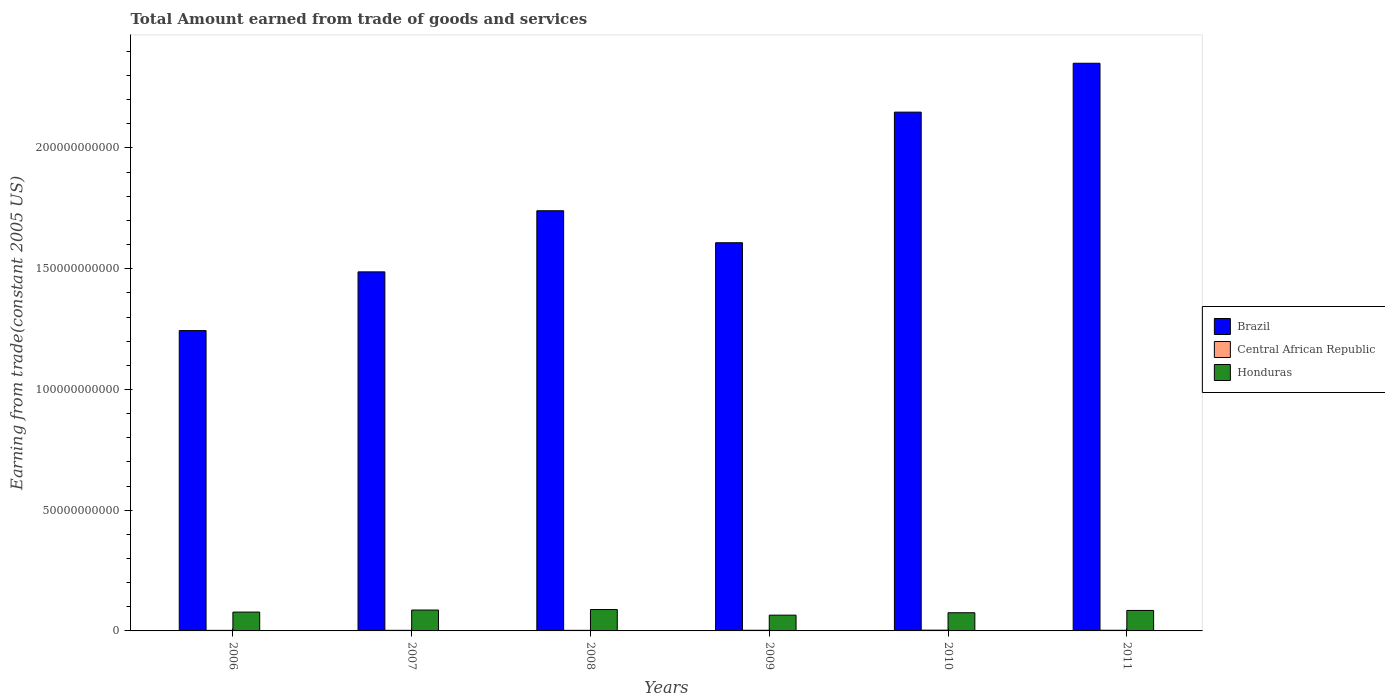How many groups of bars are there?
Your response must be concise. 6. Are the number of bars per tick equal to the number of legend labels?
Offer a terse response. Yes. Are the number of bars on each tick of the X-axis equal?
Offer a terse response. Yes. How many bars are there on the 6th tick from the left?
Your answer should be very brief. 3. What is the label of the 5th group of bars from the left?
Ensure brevity in your answer.  2010. In how many cases, is the number of bars for a given year not equal to the number of legend labels?
Provide a succinct answer. 0. What is the total amount earned by trading goods and services in Honduras in 2008?
Keep it short and to the point. 8.85e+09. Across all years, what is the maximum total amount earned by trading goods and services in Honduras?
Ensure brevity in your answer.  8.85e+09. Across all years, what is the minimum total amount earned by trading goods and services in Central African Republic?
Your answer should be very brief. 2.32e+08. In which year was the total amount earned by trading goods and services in Brazil minimum?
Make the answer very short. 2006. What is the total total amount earned by trading goods and services in Brazil in the graph?
Your answer should be very brief. 1.06e+12. What is the difference between the total amount earned by trading goods and services in Honduras in 2006 and that in 2007?
Provide a short and direct response. -8.49e+08. What is the difference between the total amount earned by trading goods and services in Brazil in 2011 and the total amount earned by trading goods and services in Central African Republic in 2006?
Your answer should be very brief. 2.35e+11. What is the average total amount earned by trading goods and services in Brazil per year?
Your answer should be very brief. 1.76e+11. In the year 2010, what is the difference between the total amount earned by trading goods and services in Central African Republic and total amount earned by trading goods and services in Brazil?
Your response must be concise. -2.15e+11. In how many years, is the total amount earned by trading goods and services in Brazil greater than 120000000000 US$?
Provide a short and direct response. 6. What is the ratio of the total amount earned by trading goods and services in Brazil in 2006 to that in 2007?
Provide a short and direct response. 0.84. Is the total amount earned by trading goods and services in Honduras in 2006 less than that in 2011?
Provide a succinct answer. Yes. Is the difference between the total amount earned by trading goods and services in Central African Republic in 2007 and 2009 greater than the difference between the total amount earned by trading goods and services in Brazil in 2007 and 2009?
Give a very brief answer. Yes. What is the difference between the highest and the second highest total amount earned by trading goods and services in Central African Republic?
Ensure brevity in your answer.  3.98e+07. What is the difference between the highest and the lowest total amount earned by trading goods and services in Central African Republic?
Provide a short and direct response. 8.47e+07. Is the sum of the total amount earned by trading goods and services in Central African Republic in 2006 and 2007 greater than the maximum total amount earned by trading goods and services in Brazil across all years?
Make the answer very short. No. What does the 2nd bar from the left in 2009 represents?
Keep it short and to the point. Central African Republic. What does the 2nd bar from the right in 2011 represents?
Your answer should be very brief. Central African Republic. Is it the case that in every year, the sum of the total amount earned by trading goods and services in Central African Republic and total amount earned by trading goods and services in Brazil is greater than the total amount earned by trading goods and services in Honduras?
Keep it short and to the point. Yes. How many bars are there?
Your response must be concise. 18. Are all the bars in the graph horizontal?
Your response must be concise. No. How many years are there in the graph?
Offer a very short reply. 6. What is the difference between two consecutive major ticks on the Y-axis?
Ensure brevity in your answer.  5.00e+1. Are the values on the major ticks of Y-axis written in scientific E-notation?
Your response must be concise. No. Does the graph contain grids?
Offer a terse response. No. What is the title of the graph?
Give a very brief answer. Total Amount earned from trade of goods and services. What is the label or title of the X-axis?
Offer a very short reply. Years. What is the label or title of the Y-axis?
Your answer should be compact. Earning from trade(constant 2005 US). What is the Earning from trade(constant 2005 US) in Brazil in 2006?
Give a very brief answer. 1.24e+11. What is the Earning from trade(constant 2005 US) of Central African Republic in 2006?
Ensure brevity in your answer.  2.32e+08. What is the Earning from trade(constant 2005 US) of Honduras in 2006?
Offer a very short reply. 7.80e+09. What is the Earning from trade(constant 2005 US) of Brazil in 2007?
Provide a succinct answer. 1.49e+11. What is the Earning from trade(constant 2005 US) in Central African Republic in 2007?
Provide a succinct answer. 2.49e+08. What is the Earning from trade(constant 2005 US) of Honduras in 2007?
Your answer should be compact. 8.65e+09. What is the Earning from trade(constant 2005 US) of Brazil in 2008?
Your answer should be very brief. 1.74e+11. What is the Earning from trade(constant 2005 US) of Central African Republic in 2008?
Ensure brevity in your answer.  2.43e+08. What is the Earning from trade(constant 2005 US) of Honduras in 2008?
Your answer should be very brief. 8.85e+09. What is the Earning from trade(constant 2005 US) in Brazil in 2009?
Your answer should be very brief. 1.61e+11. What is the Earning from trade(constant 2005 US) in Central African Republic in 2009?
Give a very brief answer. 2.77e+08. What is the Earning from trade(constant 2005 US) of Honduras in 2009?
Keep it short and to the point. 6.53e+09. What is the Earning from trade(constant 2005 US) of Brazil in 2010?
Offer a terse response. 2.15e+11. What is the Earning from trade(constant 2005 US) of Central African Republic in 2010?
Your answer should be compact. 3.17e+08. What is the Earning from trade(constant 2005 US) of Honduras in 2010?
Provide a succinct answer. 7.53e+09. What is the Earning from trade(constant 2005 US) of Brazil in 2011?
Ensure brevity in your answer.  2.35e+11. What is the Earning from trade(constant 2005 US) of Central African Republic in 2011?
Offer a terse response. 2.74e+08. What is the Earning from trade(constant 2005 US) of Honduras in 2011?
Your answer should be compact. 8.48e+09. Across all years, what is the maximum Earning from trade(constant 2005 US) of Brazil?
Provide a succinct answer. 2.35e+11. Across all years, what is the maximum Earning from trade(constant 2005 US) of Central African Republic?
Provide a succinct answer. 3.17e+08. Across all years, what is the maximum Earning from trade(constant 2005 US) in Honduras?
Keep it short and to the point. 8.85e+09. Across all years, what is the minimum Earning from trade(constant 2005 US) of Brazil?
Give a very brief answer. 1.24e+11. Across all years, what is the minimum Earning from trade(constant 2005 US) of Central African Republic?
Ensure brevity in your answer.  2.32e+08. Across all years, what is the minimum Earning from trade(constant 2005 US) of Honduras?
Ensure brevity in your answer.  6.53e+09. What is the total Earning from trade(constant 2005 US) in Brazil in the graph?
Your response must be concise. 1.06e+12. What is the total Earning from trade(constant 2005 US) in Central African Republic in the graph?
Your answer should be very brief. 1.59e+09. What is the total Earning from trade(constant 2005 US) in Honduras in the graph?
Your answer should be compact. 4.78e+1. What is the difference between the Earning from trade(constant 2005 US) in Brazil in 2006 and that in 2007?
Provide a short and direct response. -2.43e+1. What is the difference between the Earning from trade(constant 2005 US) in Central African Republic in 2006 and that in 2007?
Provide a short and direct response. -1.75e+07. What is the difference between the Earning from trade(constant 2005 US) in Honduras in 2006 and that in 2007?
Your response must be concise. -8.49e+08. What is the difference between the Earning from trade(constant 2005 US) in Brazil in 2006 and that in 2008?
Keep it short and to the point. -4.96e+1. What is the difference between the Earning from trade(constant 2005 US) in Central African Republic in 2006 and that in 2008?
Your answer should be compact. -1.07e+07. What is the difference between the Earning from trade(constant 2005 US) in Honduras in 2006 and that in 2008?
Your answer should be compact. -1.05e+09. What is the difference between the Earning from trade(constant 2005 US) of Brazil in 2006 and that in 2009?
Give a very brief answer. -3.64e+1. What is the difference between the Earning from trade(constant 2005 US) of Central African Republic in 2006 and that in 2009?
Ensure brevity in your answer.  -4.49e+07. What is the difference between the Earning from trade(constant 2005 US) in Honduras in 2006 and that in 2009?
Your answer should be very brief. 1.27e+09. What is the difference between the Earning from trade(constant 2005 US) of Brazil in 2006 and that in 2010?
Ensure brevity in your answer.  -9.05e+1. What is the difference between the Earning from trade(constant 2005 US) in Central African Republic in 2006 and that in 2010?
Offer a very short reply. -8.47e+07. What is the difference between the Earning from trade(constant 2005 US) of Honduras in 2006 and that in 2010?
Your response must be concise. 2.72e+08. What is the difference between the Earning from trade(constant 2005 US) in Brazil in 2006 and that in 2011?
Your answer should be very brief. -1.11e+11. What is the difference between the Earning from trade(constant 2005 US) in Central African Republic in 2006 and that in 2011?
Provide a succinct answer. -4.21e+07. What is the difference between the Earning from trade(constant 2005 US) in Honduras in 2006 and that in 2011?
Your response must be concise. -6.81e+08. What is the difference between the Earning from trade(constant 2005 US) of Brazil in 2007 and that in 2008?
Provide a short and direct response. -2.53e+1. What is the difference between the Earning from trade(constant 2005 US) in Central African Republic in 2007 and that in 2008?
Provide a short and direct response. 6.75e+06. What is the difference between the Earning from trade(constant 2005 US) in Honduras in 2007 and that in 2008?
Offer a very short reply. -2.06e+08. What is the difference between the Earning from trade(constant 2005 US) of Brazil in 2007 and that in 2009?
Make the answer very short. -1.21e+1. What is the difference between the Earning from trade(constant 2005 US) in Central African Republic in 2007 and that in 2009?
Offer a terse response. -2.74e+07. What is the difference between the Earning from trade(constant 2005 US) in Honduras in 2007 and that in 2009?
Offer a terse response. 2.11e+09. What is the difference between the Earning from trade(constant 2005 US) in Brazil in 2007 and that in 2010?
Ensure brevity in your answer.  -6.62e+1. What is the difference between the Earning from trade(constant 2005 US) of Central African Republic in 2007 and that in 2010?
Offer a terse response. -6.72e+07. What is the difference between the Earning from trade(constant 2005 US) in Honduras in 2007 and that in 2010?
Your response must be concise. 1.12e+09. What is the difference between the Earning from trade(constant 2005 US) in Brazil in 2007 and that in 2011?
Offer a very short reply. -8.64e+1. What is the difference between the Earning from trade(constant 2005 US) in Central African Republic in 2007 and that in 2011?
Give a very brief answer. -2.46e+07. What is the difference between the Earning from trade(constant 2005 US) of Honduras in 2007 and that in 2011?
Provide a succinct answer. 1.68e+08. What is the difference between the Earning from trade(constant 2005 US) in Brazil in 2008 and that in 2009?
Ensure brevity in your answer.  1.32e+1. What is the difference between the Earning from trade(constant 2005 US) in Central African Republic in 2008 and that in 2009?
Your response must be concise. -3.42e+07. What is the difference between the Earning from trade(constant 2005 US) in Honduras in 2008 and that in 2009?
Your answer should be compact. 2.32e+09. What is the difference between the Earning from trade(constant 2005 US) in Brazil in 2008 and that in 2010?
Offer a very short reply. -4.08e+1. What is the difference between the Earning from trade(constant 2005 US) in Central African Republic in 2008 and that in 2010?
Provide a succinct answer. -7.40e+07. What is the difference between the Earning from trade(constant 2005 US) in Honduras in 2008 and that in 2010?
Ensure brevity in your answer.  1.33e+09. What is the difference between the Earning from trade(constant 2005 US) of Brazil in 2008 and that in 2011?
Ensure brevity in your answer.  -6.11e+1. What is the difference between the Earning from trade(constant 2005 US) of Central African Republic in 2008 and that in 2011?
Your response must be concise. -3.13e+07. What is the difference between the Earning from trade(constant 2005 US) in Honduras in 2008 and that in 2011?
Your response must be concise. 3.74e+08. What is the difference between the Earning from trade(constant 2005 US) of Brazil in 2009 and that in 2010?
Your response must be concise. -5.41e+1. What is the difference between the Earning from trade(constant 2005 US) in Central African Republic in 2009 and that in 2010?
Keep it short and to the point. -3.98e+07. What is the difference between the Earning from trade(constant 2005 US) in Honduras in 2009 and that in 2010?
Your response must be concise. -9.93e+08. What is the difference between the Earning from trade(constant 2005 US) in Brazil in 2009 and that in 2011?
Ensure brevity in your answer.  -7.43e+1. What is the difference between the Earning from trade(constant 2005 US) in Central African Republic in 2009 and that in 2011?
Your answer should be compact. 2.83e+06. What is the difference between the Earning from trade(constant 2005 US) in Honduras in 2009 and that in 2011?
Ensure brevity in your answer.  -1.95e+09. What is the difference between the Earning from trade(constant 2005 US) in Brazil in 2010 and that in 2011?
Your answer should be compact. -2.02e+1. What is the difference between the Earning from trade(constant 2005 US) in Central African Republic in 2010 and that in 2011?
Keep it short and to the point. 4.26e+07. What is the difference between the Earning from trade(constant 2005 US) in Honduras in 2010 and that in 2011?
Give a very brief answer. -9.53e+08. What is the difference between the Earning from trade(constant 2005 US) in Brazil in 2006 and the Earning from trade(constant 2005 US) in Central African Republic in 2007?
Your answer should be very brief. 1.24e+11. What is the difference between the Earning from trade(constant 2005 US) of Brazil in 2006 and the Earning from trade(constant 2005 US) of Honduras in 2007?
Your response must be concise. 1.16e+11. What is the difference between the Earning from trade(constant 2005 US) in Central African Republic in 2006 and the Earning from trade(constant 2005 US) in Honduras in 2007?
Your response must be concise. -8.42e+09. What is the difference between the Earning from trade(constant 2005 US) in Brazil in 2006 and the Earning from trade(constant 2005 US) in Central African Republic in 2008?
Make the answer very short. 1.24e+11. What is the difference between the Earning from trade(constant 2005 US) of Brazil in 2006 and the Earning from trade(constant 2005 US) of Honduras in 2008?
Your answer should be compact. 1.16e+11. What is the difference between the Earning from trade(constant 2005 US) in Central African Republic in 2006 and the Earning from trade(constant 2005 US) in Honduras in 2008?
Ensure brevity in your answer.  -8.62e+09. What is the difference between the Earning from trade(constant 2005 US) of Brazil in 2006 and the Earning from trade(constant 2005 US) of Central African Republic in 2009?
Your answer should be compact. 1.24e+11. What is the difference between the Earning from trade(constant 2005 US) of Brazil in 2006 and the Earning from trade(constant 2005 US) of Honduras in 2009?
Your answer should be very brief. 1.18e+11. What is the difference between the Earning from trade(constant 2005 US) of Central African Republic in 2006 and the Earning from trade(constant 2005 US) of Honduras in 2009?
Your response must be concise. -6.30e+09. What is the difference between the Earning from trade(constant 2005 US) of Brazil in 2006 and the Earning from trade(constant 2005 US) of Central African Republic in 2010?
Keep it short and to the point. 1.24e+11. What is the difference between the Earning from trade(constant 2005 US) of Brazil in 2006 and the Earning from trade(constant 2005 US) of Honduras in 2010?
Keep it short and to the point. 1.17e+11. What is the difference between the Earning from trade(constant 2005 US) in Central African Republic in 2006 and the Earning from trade(constant 2005 US) in Honduras in 2010?
Your answer should be very brief. -7.29e+09. What is the difference between the Earning from trade(constant 2005 US) in Brazil in 2006 and the Earning from trade(constant 2005 US) in Central African Republic in 2011?
Ensure brevity in your answer.  1.24e+11. What is the difference between the Earning from trade(constant 2005 US) in Brazil in 2006 and the Earning from trade(constant 2005 US) in Honduras in 2011?
Provide a short and direct response. 1.16e+11. What is the difference between the Earning from trade(constant 2005 US) of Central African Republic in 2006 and the Earning from trade(constant 2005 US) of Honduras in 2011?
Give a very brief answer. -8.25e+09. What is the difference between the Earning from trade(constant 2005 US) of Brazil in 2007 and the Earning from trade(constant 2005 US) of Central African Republic in 2008?
Offer a very short reply. 1.48e+11. What is the difference between the Earning from trade(constant 2005 US) in Brazil in 2007 and the Earning from trade(constant 2005 US) in Honduras in 2008?
Offer a terse response. 1.40e+11. What is the difference between the Earning from trade(constant 2005 US) in Central African Republic in 2007 and the Earning from trade(constant 2005 US) in Honduras in 2008?
Make the answer very short. -8.60e+09. What is the difference between the Earning from trade(constant 2005 US) of Brazil in 2007 and the Earning from trade(constant 2005 US) of Central African Republic in 2009?
Make the answer very short. 1.48e+11. What is the difference between the Earning from trade(constant 2005 US) of Brazil in 2007 and the Earning from trade(constant 2005 US) of Honduras in 2009?
Give a very brief answer. 1.42e+11. What is the difference between the Earning from trade(constant 2005 US) in Central African Republic in 2007 and the Earning from trade(constant 2005 US) in Honduras in 2009?
Your answer should be very brief. -6.28e+09. What is the difference between the Earning from trade(constant 2005 US) in Brazil in 2007 and the Earning from trade(constant 2005 US) in Central African Republic in 2010?
Ensure brevity in your answer.  1.48e+11. What is the difference between the Earning from trade(constant 2005 US) in Brazil in 2007 and the Earning from trade(constant 2005 US) in Honduras in 2010?
Provide a succinct answer. 1.41e+11. What is the difference between the Earning from trade(constant 2005 US) in Central African Republic in 2007 and the Earning from trade(constant 2005 US) in Honduras in 2010?
Provide a short and direct response. -7.28e+09. What is the difference between the Earning from trade(constant 2005 US) in Brazil in 2007 and the Earning from trade(constant 2005 US) in Central African Republic in 2011?
Provide a succinct answer. 1.48e+11. What is the difference between the Earning from trade(constant 2005 US) of Brazil in 2007 and the Earning from trade(constant 2005 US) of Honduras in 2011?
Keep it short and to the point. 1.40e+11. What is the difference between the Earning from trade(constant 2005 US) of Central African Republic in 2007 and the Earning from trade(constant 2005 US) of Honduras in 2011?
Keep it short and to the point. -8.23e+09. What is the difference between the Earning from trade(constant 2005 US) of Brazil in 2008 and the Earning from trade(constant 2005 US) of Central African Republic in 2009?
Your response must be concise. 1.74e+11. What is the difference between the Earning from trade(constant 2005 US) of Brazil in 2008 and the Earning from trade(constant 2005 US) of Honduras in 2009?
Your answer should be compact. 1.67e+11. What is the difference between the Earning from trade(constant 2005 US) of Central African Republic in 2008 and the Earning from trade(constant 2005 US) of Honduras in 2009?
Ensure brevity in your answer.  -6.29e+09. What is the difference between the Earning from trade(constant 2005 US) in Brazil in 2008 and the Earning from trade(constant 2005 US) in Central African Republic in 2010?
Offer a terse response. 1.74e+11. What is the difference between the Earning from trade(constant 2005 US) in Brazil in 2008 and the Earning from trade(constant 2005 US) in Honduras in 2010?
Your response must be concise. 1.66e+11. What is the difference between the Earning from trade(constant 2005 US) of Central African Republic in 2008 and the Earning from trade(constant 2005 US) of Honduras in 2010?
Your response must be concise. -7.28e+09. What is the difference between the Earning from trade(constant 2005 US) in Brazil in 2008 and the Earning from trade(constant 2005 US) in Central African Republic in 2011?
Ensure brevity in your answer.  1.74e+11. What is the difference between the Earning from trade(constant 2005 US) in Brazil in 2008 and the Earning from trade(constant 2005 US) in Honduras in 2011?
Offer a terse response. 1.66e+11. What is the difference between the Earning from trade(constant 2005 US) in Central African Republic in 2008 and the Earning from trade(constant 2005 US) in Honduras in 2011?
Keep it short and to the point. -8.24e+09. What is the difference between the Earning from trade(constant 2005 US) in Brazil in 2009 and the Earning from trade(constant 2005 US) in Central African Republic in 2010?
Your answer should be compact. 1.60e+11. What is the difference between the Earning from trade(constant 2005 US) in Brazil in 2009 and the Earning from trade(constant 2005 US) in Honduras in 2010?
Give a very brief answer. 1.53e+11. What is the difference between the Earning from trade(constant 2005 US) in Central African Republic in 2009 and the Earning from trade(constant 2005 US) in Honduras in 2010?
Give a very brief answer. -7.25e+09. What is the difference between the Earning from trade(constant 2005 US) in Brazil in 2009 and the Earning from trade(constant 2005 US) in Central African Republic in 2011?
Your response must be concise. 1.60e+11. What is the difference between the Earning from trade(constant 2005 US) in Brazil in 2009 and the Earning from trade(constant 2005 US) in Honduras in 2011?
Offer a very short reply. 1.52e+11. What is the difference between the Earning from trade(constant 2005 US) in Central African Republic in 2009 and the Earning from trade(constant 2005 US) in Honduras in 2011?
Your answer should be compact. -8.20e+09. What is the difference between the Earning from trade(constant 2005 US) in Brazil in 2010 and the Earning from trade(constant 2005 US) in Central African Republic in 2011?
Offer a terse response. 2.15e+11. What is the difference between the Earning from trade(constant 2005 US) of Brazil in 2010 and the Earning from trade(constant 2005 US) of Honduras in 2011?
Make the answer very short. 2.06e+11. What is the difference between the Earning from trade(constant 2005 US) of Central African Republic in 2010 and the Earning from trade(constant 2005 US) of Honduras in 2011?
Your response must be concise. -8.16e+09. What is the average Earning from trade(constant 2005 US) of Brazil per year?
Your answer should be compact. 1.76e+11. What is the average Earning from trade(constant 2005 US) in Central African Republic per year?
Your answer should be compact. 2.65e+08. What is the average Earning from trade(constant 2005 US) of Honduras per year?
Provide a short and direct response. 7.97e+09. In the year 2006, what is the difference between the Earning from trade(constant 2005 US) of Brazil and Earning from trade(constant 2005 US) of Central African Republic?
Provide a short and direct response. 1.24e+11. In the year 2006, what is the difference between the Earning from trade(constant 2005 US) in Brazil and Earning from trade(constant 2005 US) in Honduras?
Provide a short and direct response. 1.17e+11. In the year 2006, what is the difference between the Earning from trade(constant 2005 US) of Central African Republic and Earning from trade(constant 2005 US) of Honduras?
Offer a terse response. -7.57e+09. In the year 2007, what is the difference between the Earning from trade(constant 2005 US) in Brazil and Earning from trade(constant 2005 US) in Central African Republic?
Your answer should be very brief. 1.48e+11. In the year 2007, what is the difference between the Earning from trade(constant 2005 US) of Brazil and Earning from trade(constant 2005 US) of Honduras?
Offer a terse response. 1.40e+11. In the year 2007, what is the difference between the Earning from trade(constant 2005 US) in Central African Republic and Earning from trade(constant 2005 US) in Honduras?
Provide a succinct answer. -8.40e+09. In the year 2008, what is the difference between the Earning from trade(constant 2005 US) in Brazil and Earning from trade(constant 2005 US) in Central African Republic?
Make the answer very short. 1.74e+11. In the year 2008, what is the difference between the Earning from trade(constant 2005 US) of Brazil and Earning from trade(constant 2005 US) of Honduras?
Ensure brevity in your answer.  1.65e+11. In the year 2008, what is the difference between the Earning from trade(constant 2005 US) in Central African Republic and Earning from trade(constant 2005 US) in Honduras?
Offer a very short reply. -8.61e+09. In the year 2009, what is the difference between the Earning from trade(constant 2005 US) in Brazil and Earning from trade(constant 2005 US) in Central African Republic?
Offer a terse response. 1.60e+11. In the year 2009, what is the difference between the Earning from trade(constant 2005 US) of Brazil and Earning from trade(constant 2005 US) of Honduras?
Your answer should be compact. 1.54e+11. In the year 2009, what is the difference between the Earning from trade(constant 2005 US) of Central African Republic and Earning from trade(constant 2005 US) of Honduras?
Your response must be concise. -6.26e+09. In the year 2010, what is the difference between the Earning from trade(constant 2005 US) in Brazil and Earning from trade(constant 2005 US) in Central African Republic?
Make the answer very short. 2.15e+11. In the year 2010, what is the difference between the Earning from trade(constant 2005 US) in Brazil and Earning from trade(constant 2005 US) in Honduras?
Make the answer very short. 2.07e+11. In the year 2010, what is the difference between the Earning from trade(constant 2005 US) in Central African Republic and Earning from trade(constant 2005 US) in Honduras?
Offer a very short reply. -7.21e+09. In the year 2011, what is the difference between the Earning from trade(constant 2005 US) of Brazil and Earning from trade(constant 2005 US) of Central African Republic?
Ensure brevity in your answer.  2.35e+11. In the year 2011, what is the difference between the Earning from trade(constant 2005 US) in Brazil and Earning from trade(constant 2005 US) in Honduras?
Provide a short and direct response. 2.27e+11. In the year 2011, what is the difference between the Earning from trade(constant 2005 US) in Central African Republic and Earning from trade(constant 2005 US) in Honduras?
Your answer should be compact. -8.21e+09. What is the ratio of the Earning from trade(constant 2005 US) in Brazil in 2006 to that in 2007?
Offer a terse response. 0.84. What is the ratio of the Earning from trade(constant 2005 US) in Central African Republic in 2006 to that in 2007?
Provide a short and direct response. 0.93. What is the ratio of the Earning from trade(constant 2005 US) of Honduras in 2006 to that in 2007?
Give a very brief answer. 0.9. What is the ratio of the Earning from trade(constant 2005 US) in Brazil in 2006 to that in 2008?
Provide a succinct answer. 0.71. What is the ratio of the Earning from trade(constant 2005 US) in Central African Republic in 2006 to that in 2008?
Your answer should be very brief. 0.96. What is the ratio of the Earning from trade(constant 2005 US) in Honduras in 2006 to that in 2008?
Your answer should be very brief. 0.88. What is the ratio of the Earning from trade(constant 2005 US) of Brazil in 2006 to that in 2009?
Your response must be concise. 0.77. What is the ratio of the Earning from trade(constant 2005 US) of Central African Republic in 2006 to that in 2009?
Keep it short and to the point. 0.84. What is the ratio of the Earning from trade(constant 2005 US) in Honduras in 2006 to that in 2009?
Offer a terse response. 1.19. What is the ratio of the Earning from trade(constant 2005 US) of Brazil in 2006 to that in 2010?
Offer a terse response. 0.58. What is the ratio of the Earning from trade(constant 2005 US) of Central African Republic in 2006 to that in 2010?
Keep it short and to the point. 0.73. What is the ratio of the Earning from trade(constant 2005 US) of Honduras in 2006 to that in 2010?
Keep it short and to the point. 1.04. What is the ratio of the Earning from trade(constant 2005 US) of Brazil in 2006 to that in 2011?
Your answer should be very brief. 0.53. What is the ratio of the Earning from trade(constant 2005 US) in Central African Republic in 2006 to that in 2011?
Provide a short and direct response. 0.85. What is the ratio of the Earning from trade(constant 2005 US) of Honduras in 2006 to that in 2011?
Your response must be concise. 0.92. What is the ratio of the Earning from trade(constant 2005 US) in Brazil in 2007 to that in 2008?
Keep it short and to the point. 0.85. What is the ratio of the Earning from trade(constant 2005 US) of Central African Republic in 2007 to that in 2008?
Provide a short and direct response. 1.03. What is the ratio of the Earning from trade(constant 2005 US) in Honduras in 2007 to that in 2008?
Your response must be concise. 0.98. What is the ratio of the Earning from trade(constant 2005 US) of Brazil in 2007 to that in 2009?
Keep it short and to the point. 0.92. What is the ratio of the Earning from trade(constant 2005 US) in Central African Republic in 2007 to that in 2009?
Provide a short and direct response. 0.9. What is the ratio of the Earning from trade(constant 2005 US) in Honduras in 2007 to that in 2009?
Your answer should be compact. 1.32. What is the ratio of the Earning from trade(constant 2005 US) in Brazil in 2007 to that in 2010?
Your answer should be very brief. 0.69. What is the ratio of the Earning from trade(constant 2005 US) in Central African Republic in 2007 to that in 2010?
Offer a very short reply. 0.79. What is the ratio of the Earning from trade(constant 2005 US) in Honduras in 2007 to that in 2010?
Make the answer very short. 1.15. What is the ratio of the Earning from trade(constant 2005 US) in Brazil in 2007 to that in 2011?
Make the answer very short. 0.63. What is the ratio of the Earning from trade(constant 2005 US) of Central African Republic in 2007 to that in 2011?
Make the answer very short. 0.91. What is the ratio of the Earning from trade(constant 2005 US) in Honduras in 2007 to that in 2011?
Offer a terse response. 1.02. What is the ratio of the Earning from trade(constant 2005 US) in Brazil in 2008 to that in 2009?
Your response must be concise. 1.08. What is the ratio of the Earning from trade(constant 2005 US) in Central African Republic in 2008 to that in 2009?
Your response must be concise. 0.88. What is the ratio of the Earning from trade(constant 2005 US) of Honduras in 2008 to that in 2009?
Keep it short and to the point. 1.36. What is the ratio of the Earning from trade(constant 2005 US) in Brazil in 2008 to that in 2010?
Your response must be concise. 0.81. What is the ratio of the Earning from trade(constant 2005 US) in Central African Republic in 2008 to that in 2010?
Keep it short and to the point. 0.77. What is the ratio of the Earning from trade(constant 2005 US) of Honduras in 2008 to that in 2010?
Ensure brevity in your answer.  1.18. What is the ratio of the Earning from trade(constant 2005 US) of Brazil in 2008 to that in 2011?
Your answer should be compact. 0.74. What is the ratio of the Earning from trade(constant 2005 US) of Central African Republic in 2008 to that in 2011?
Your response must be concise. 0.89. What is the ratio of the Earning from trade(constant 2005 US) of Honduras in 2008 to that in 2011?
Your response must be concise. 1.04. What is the ratio of the Earning from trade(constant 2005 US) of Brazil in 2009 to that in 2010?
Keep it short and to the point. 0.75. What is the ratio of the Earning from trade(constant 2005 US) of Central African Republic in 2009 to that in 2010?
Provide a succinct answer. 0.87. What is the ratio of the Earning from trade(constant 2005 US) in Honduras in 2009 to that in 2010?
Keep it short and to the point. 0.87. What is the ratio of the Earning from trade(constant 2005 US) in Brazil in 2009 to that in 2011?
Your answer should be compact. 0.68. What is the ratio of the Earning from trade(constant 2005 US) in Central African Republic in 2009 to that in 2011?
Ensure brevity in your answer.  1.01. What is the ratio of the Earning from trade(constant 2005 US) of Honduras in 2009 to that in 2011?
Your answer should be very brief. 0.77. What is the ratio of the Earning from trade(constant 2005 US) in Brazil in 2010 to that in 2011?
Offer a very short reply. 0.91. What is the ratio of the Earning from trade(constant 2005 US) in Central African Republic in 2010 to that in 2011?
Provide a succinct answer. 1.16. What is the ratio of the Earning from trade(constant 2005 US) of Honduras in 2010 to that in 2011?
Keep it short and to the point. 0.89. What is the difference between the highest and the second highest Earning from trade(constant 2005 US) in Brazil?
Your answer should be compact. 2.02e+1. What is the difference between the highest and the second highest Earning from trade(constant 2005 US) in Central African Republic?
Give a very brief answer. 3.98e+07. What is the difference between the highest and the second highest Earning from trade(constant 2005 US) of Honduras?
Offer a terse response. 2.06e+08. What is the difference between the highest and the lowest Earning from trade(constant 2005 US) in Brazil?
Provide a succinct answer. 1.11e+11. What is the difference between the highest and the lowest Earning from trade(constant 2005 US) in Central African Republic?
Offer a very short reply. 8.47e+07. What is the difference between the highest and the lowest Earning from trade(constant 2005 US) in Honduras?
Keep it short and to the point. 2.32e+09. 